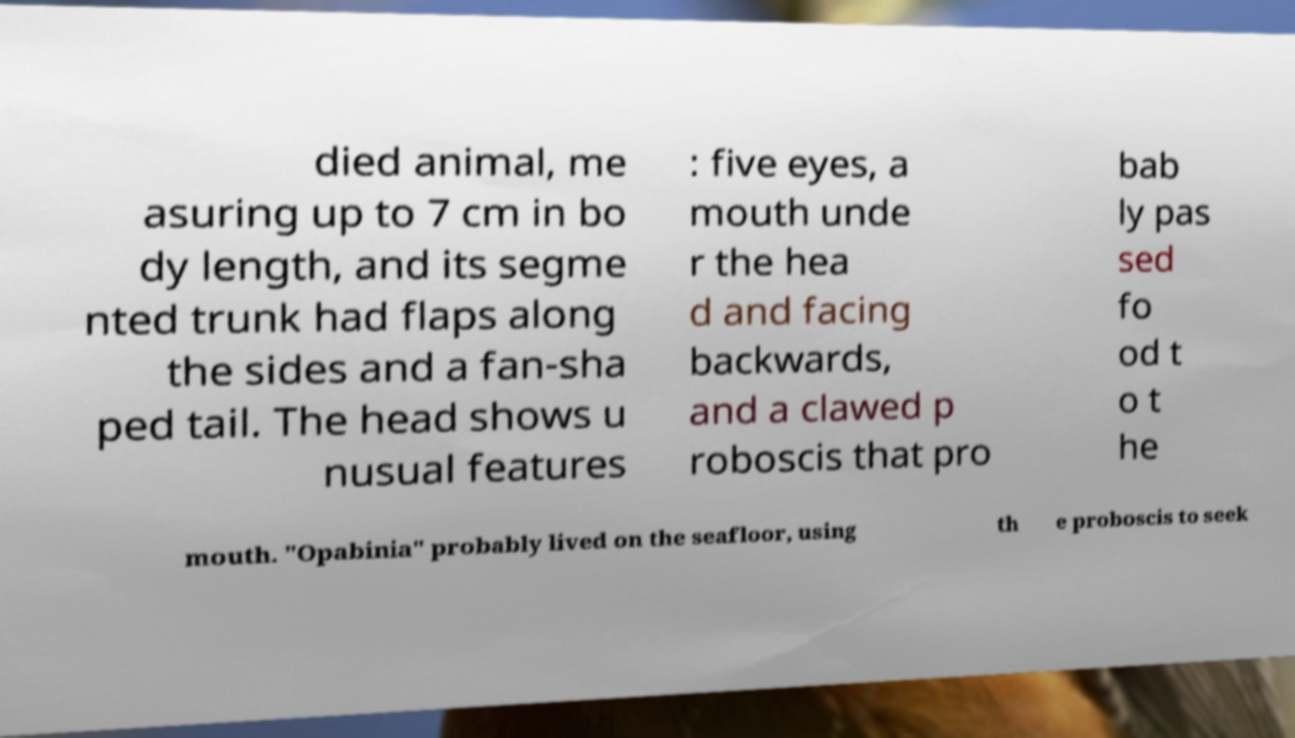There's text embedded in this image that I need extracted. Can you transcribe it verbatim? died animal, me asuring up to 7 cm in bo dy length, and its segme nted trunk had flaps along the sides and a fan-sha ped tail. The head shows u nusual features : five eyes, a mouth unde r the hea d and facing backwards, and a clawed p roboscis that pro bab ly pas sed fo od t o t he mouth. "Opabinia" probably lived on the seafloor, using th e proboscis to seek 